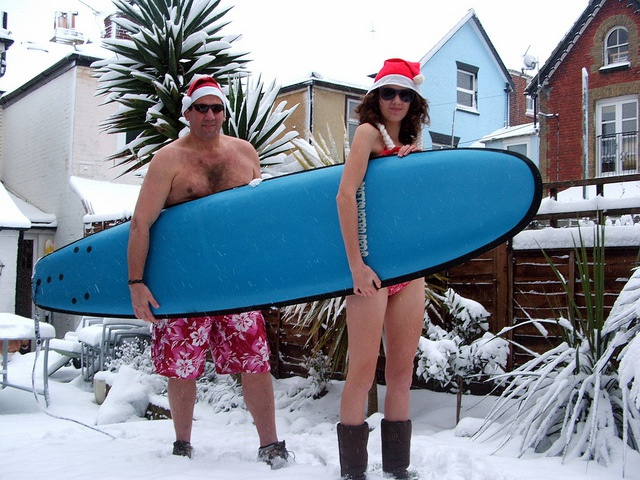Describe the objects in this image and their specific colors. I can see surfboard in white, teal, blue, and black tones, people in white, brown, maroon, and black tones, people in white, brown, black, and maroon tones, chair in white, lightgray, darkgray, and gray tones, and chair in white, gray, darkgray, and black tones in this image. 